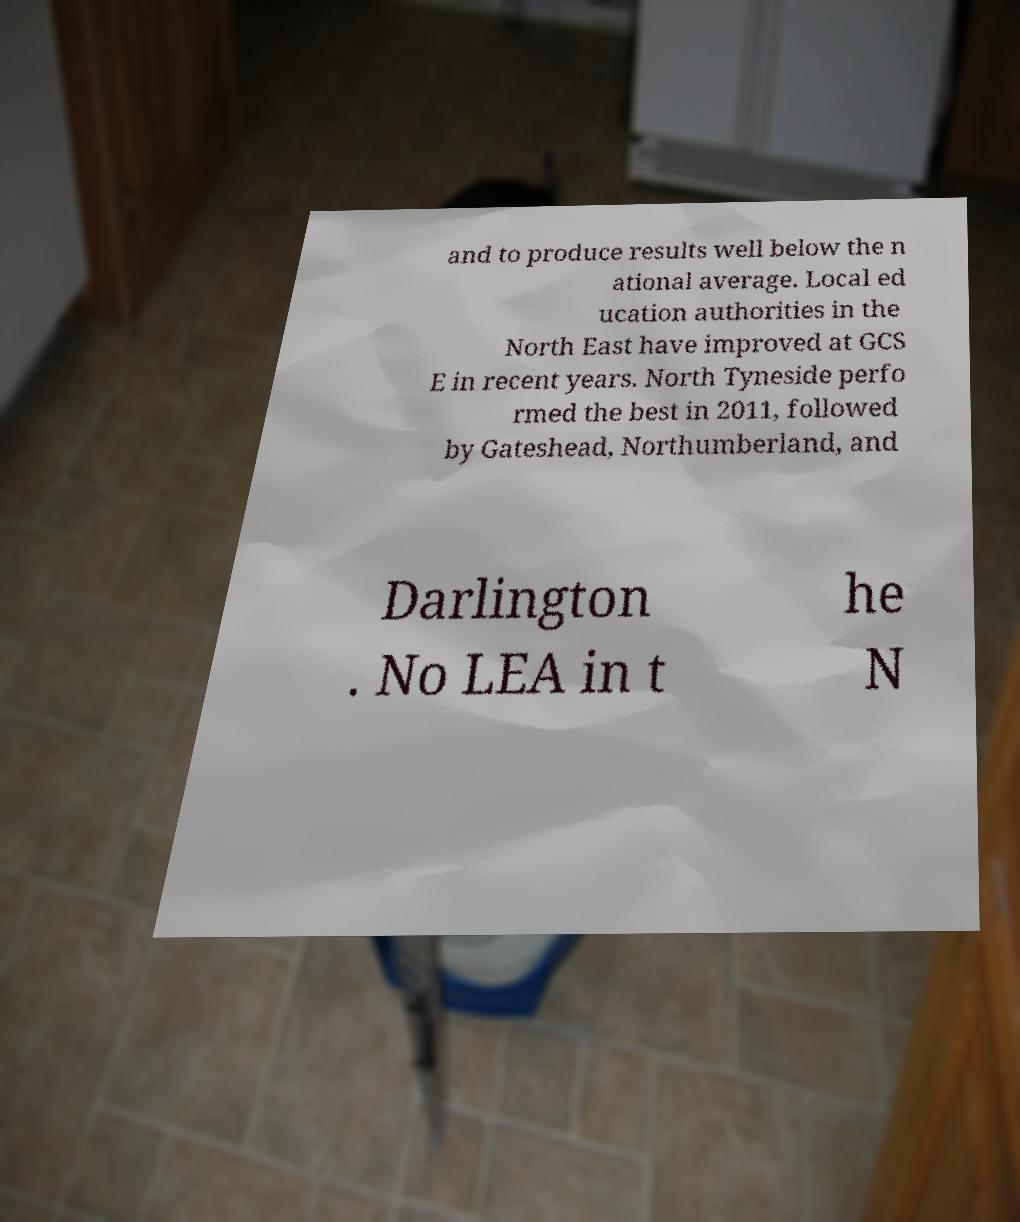What messages or text are displayed in this image? I need them in a readable, typed format. and to produce results well below the n ational average. Local ed ucation authorities in the North East have improved at GCS E in recent years. North Tyneside perfo rmed the best in 2011, followed by Gateshead, Northumberland, and Darlington . No LEA in t he N 